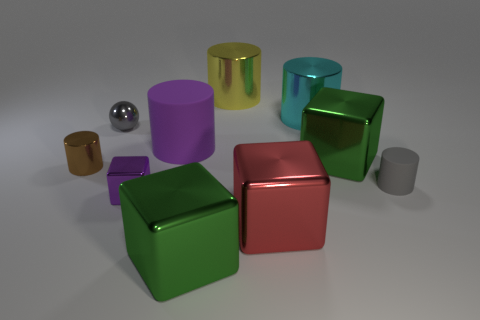There is a tiny sphere; is it the same color as the small object that is on the right side of the small purple metal block?
Provide a short and direct response. Yes. There is a big shiny cube on the right side of the cyan object; is its color the same as the tiny ball?
Offer a very short reply. No. How many things are either large purple cylinders or small things in front of the purple rubber cylinder?
Make the answer very short. 4. What material is the cylinder that is in front of the tiny shiny ball and right of the yellow metal thing?
Provide a succinct answer. Rubber. There is a gray object right of the tiny purple thing; what is its material?
Provide a short and direct response. Rubber. There is a sphere that is the same material as the tiny purple cube; what color is it?
Ensure brevity in your answer.  Gray. There is a big red metallic thing; is its shape the same as the purple thing in front of the big rubber thing?
Ensure brevity in your answer.  Yes. There is a purple matte cylinder; are there any tiny things on the right side of it?
Offer a terse response. Yes. There is a small thing that is the same color as the metallic sphere; what material is it?
Offer a terse response. Rubber. Do the brown cylinder and the gray object that is in front of the ball have the same size?
Offer a terse response. Yes. 